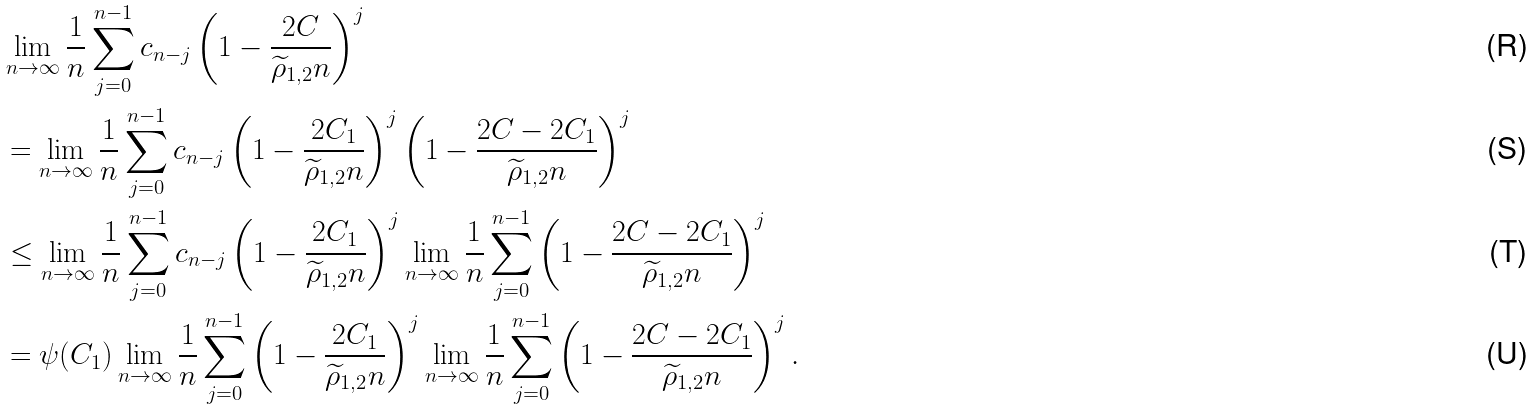Convert formula to latex. <formula><loc_0><loc_0><loc_500><loc_500>& \lim _ { n \to \infty } \frac { 1 } { n } \sum _ { j = 0 } ^ { n - 1 } c _ { n - j } \left ( 1 - \frac { 2 C } { \widetilde { \rho } _ { 1 , 2 } n } \right ) ^ { j } \\ & = \lim _ { n \to \infty } \frac { 1 } { n } \sum _ { j = 0 } ^ { n - 1 } c _ { n - j } \left ( 1 - \frac { 2 C _ { 1 } } { \widetilde { \rho } _ { 1 , 2 } n } \right ) ^ { j } \left ( 1 - \frac { 2 C - 2 C _ { 1 } } { \widetilde { \rho } _ { 1 , 2 } n } \right ) ^ { j } \\ & \leq \lim _ { n \to \infty } \frac { 1 } { n } \sum _ { j = 0 } ^ { n - 1 } c _ { n - j } \left ( 1 - \frac { 2 C _ { 1 } } { \widetilde { \rho } _ { 1 , 2 } n } \right ) ^ { j } \lim _ { n \to \infty } \frac { 1 } { n } \sum _ { j = 0 } ^ { n - 1 } \left ( 1 - \frac { 2 C - 2 C _ { 1 } } { \widetilde { \rho } _ { 1 , 2 } n } \right ) ^ { j } \\ & = \psi ( C _ { 1 } ) \lim _ { n \to \infty } \frac { 1 } { n } \sum _ { j = 0 } ^ { n - 1 } \left ( 1 - \frac { 2 C _ { 1 } } { \widetilde { \rho } _ { 1 , 2 } n } \right ) ^ { j } \lim _ { n \to \infty } \frac { 1 } { n } \sum _ { j = 0 } ^ { n - 1 } \left ( 1 - \frac { 2 C - 2 C _ { 1 } } { \widetilde { \rho } _ { 1 , 2 } n } \right ) ^ { j } .</formula> 